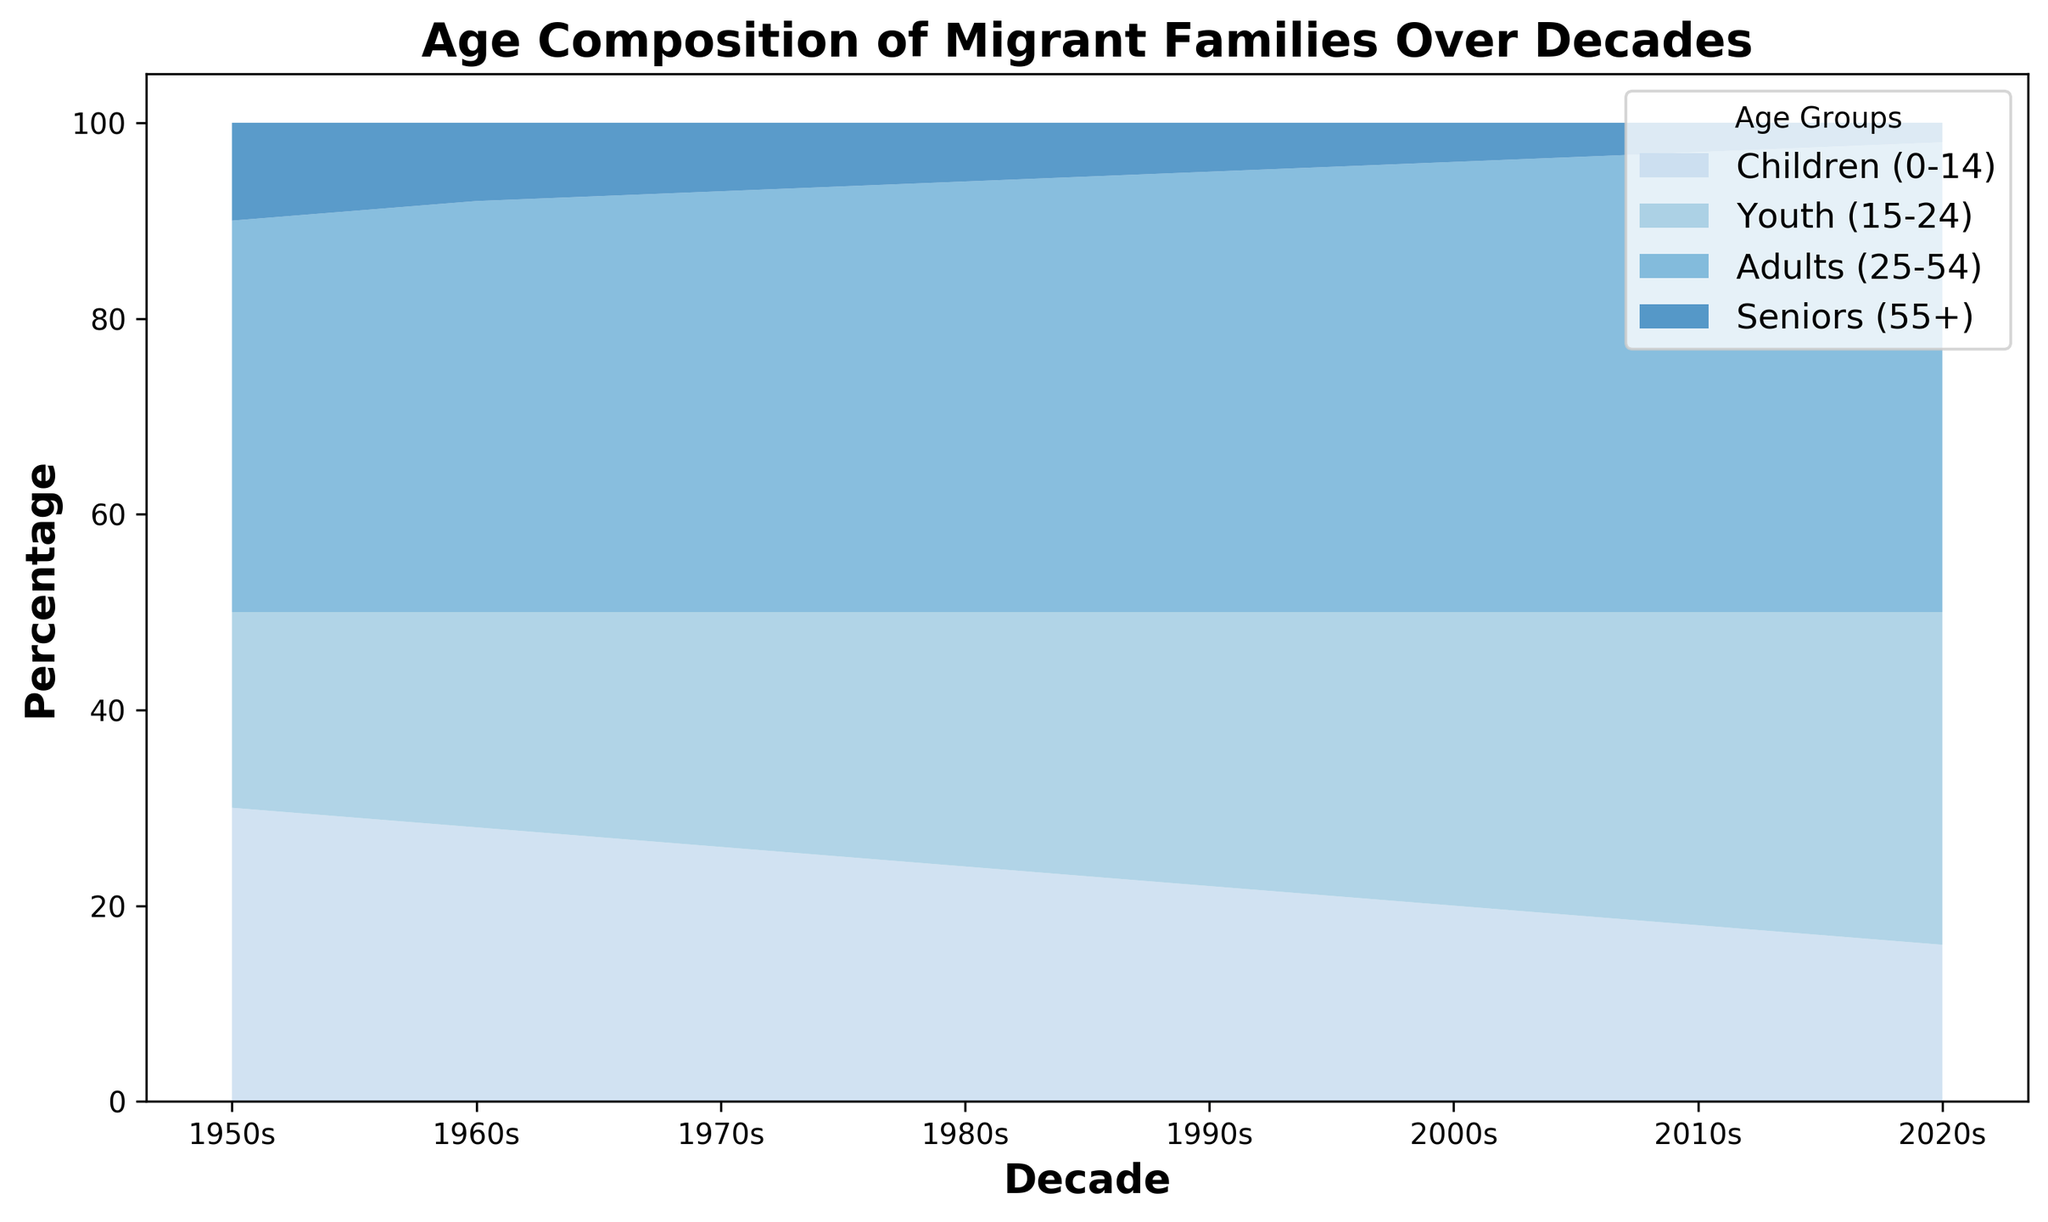How does the proportion of children (0-14) change from the 1950s to the 2020s? The proportion of children (0-14) in the 1950s is 30%, and it decreases to 16% in the 2020s. The change is calculated by subtracting the percentage in the 2020s from that in the 1950s: 30% - 16% = 14%.
Answer: It decreases by 14% Which decade shows the highest proportion of youth (15-24)? By examining the area for the youth category in each decade, the highest proportion is in the 2020s. The percentage for this group increases continuously and reaches 34% in the 2020s.
Answer: 2020s Compare the proportions of adults (25-54) and seniors (55+) in the 1980s. Which group had a higher proportion? In the 1980s, the proportion of adults (25-54) is 44%, while the proportion of seniors (55+) is 6%. Comparing these values shows that the adults have a significantly higher proportion than the seniors.
Answer: Adults (25-54) What is the difference between the proportion of seniors (55+) in the 1950s and the 2020s? The proportion of seniors (55+) in the 1950s is 10%, and in the 2020s it is 2%. The difference is calculated by subtracting the percentage in the 2020s from that in the 1950s: 10% - 2% = 8%.
Answer: 8% What trends do you observe in each age group over the decades? Reviewing trends: Children (0-14) and Seniors (55+) decrease, with Children starting at 30% and dropping to 16%, and Seniors starting at 10% and dropping to 2%. Youth (15-24) and Adults (25-54) increase, with Youth rising from 20% to 34% and Adults from 40% to 48%.
Answer: Decrease: Children, Seniors; Increase: Youth, Adults In the 1970s, what proportion of the migrant families was made up of children (0-14) and youth (15-24) combined? The proportions of children (0-14) and youth (15-24) in the 1970s are 26% and 24%, respectively. The combined proportion is calculated by adding these two values: 26% + 24% = 50%.
Answer: 50% Which age group shows the smallest change in proportion from the 1950s to the 2020s? To determine this, calculate the change for each age group: Children (14%), Youth (14%), Adults (8%), Seniors (8%). Both Adults and Seniors show the smallest change with 8%.
Answer: Adults (25-54) and Seniors (55+) What visual features make it clear which age group has increased over time? The increasing trend in Youth (15-24) and Adults (25-54) is clear from the widening areas for these groups over time, with Youth in lighter blue and Adults in a darker shade of blue. The expanding width visually indicates growth.
Answer: Widening areas of Youth and Adults 